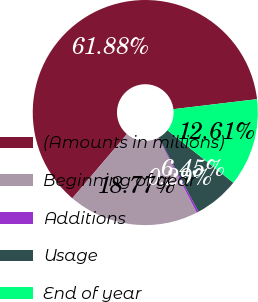Convert chart. <chart><loc_0><loc_0><loc_500><loc_500><pie_chart><fcel>(Amounts in millions)<fcel>Beginning of year<fcel>Additions<fcel>Usage<fcel>End of year<nl><fcel>61.89%<fcel>18.77%<fcel>0.29%<fcel>6.45%<fcel>12.61%<nl></chart> 